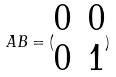<formula> <loc_0><loc_0><loc_500><loc_500>A B = ( \begin{matrix} 0 & 0 \\ 0 & 1 \end{matrix} )</formula> 